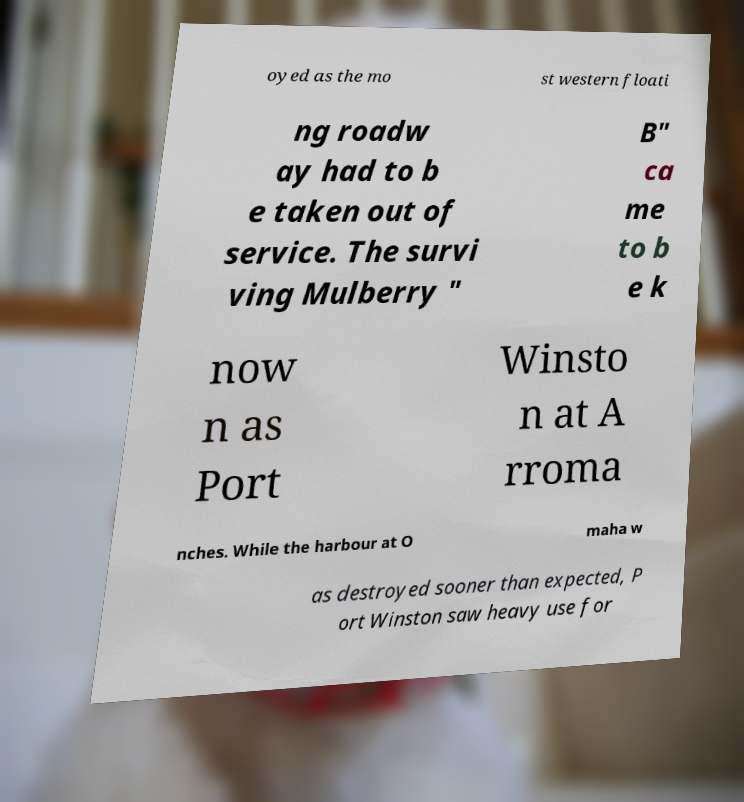What messages or text are displayed in this image? I need them in a readable, typed format. oyed as the mo st western floati ng roadw ay had to b e taken out of service. The survi ving Mulberry " B" ca me to b e k now n as Port Winsto n at A rroma nches. While the harbour at O maha w as destroyed sooner than expected, P ort Winston saw heavy use for 